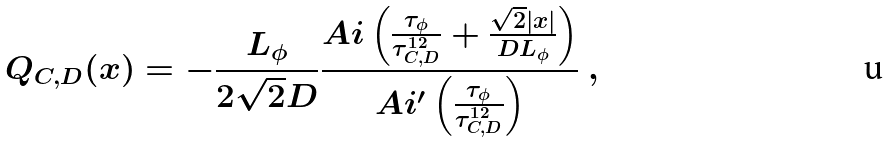Convert formula to latex. <formula><loc_0><loc_0><loc_500><loc_500>Q _ { C , D } ( x ) = - \frac { L _ { \phi } } { 2 \sqrt { 2 } D } \frac { A i \left ( \frac { \tau _ { \phi } } { \tau _ { C , D } ^ { 1 2 } } + \frac { \sqrt { 2 } | x | } { D L _ { \phi } } \right ) } { A i ^ { \prime } \left ( \frac { \tau _ { \phi } } { \tau _ { C , D } ^ { 1 2 } } \right ) } \ ,</formula> 